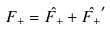Convert formula to latex. <formula><loc_0><loc_0><loc_500><loc_500>F _ { + } = \hat { F _ { + } } + \hat { F _ { + } } ^ { \prime }</formula> 